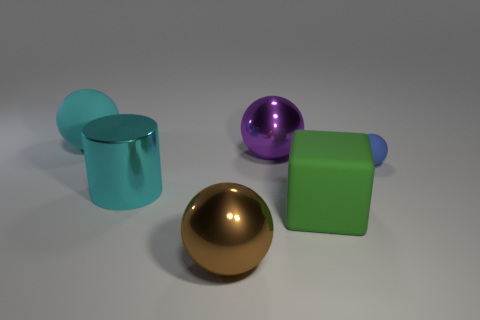There is a large object that is the same color as the big metallic cylinder; what is its shape?
Make the answer very short. Sphere. Are there fewer big purple shiny objects that are in front of the large cyan shiny thing than large purple metal things?
Your answer should be very brief. Yes. Does the ball to the left of the cyan metallic cylinder have the same size as the block?
Ensure brevity in your answer.  Yes. How many green rubber objects have the same shape as the big cyan metallic thing?
Keep it short and to the point. 0. What is the size of the cyan thing that is the same material as the purple sphere?
Provide a succinct answer. Large. Is the number of matte things that are in front of the blue thing the same as the number of big gray matte cubes?
Offer a terse response. No. Is the color of the big metallic cylinder the same as the big block?
Make the answer very short. No. Is the shape of the thing that is behind the purple metal object the same as the thing on the right side of the block?
Make the answer very short. Yes. What material is the large cyan thing that is the same shape as the large purple metal object?
Your answer should be very brief. Rubber. The matte thing that is to the left of the small rubber object and behind the green cube is what color?
Make the answer very short. Cyan. 